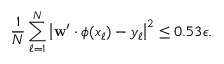<formula> <loc_0><loc_0><loc_500><loc_500>\frac { 1 } { N } \sum _ { \ell = 1 } ^ { N } \left | w ^ { \prime } \cdot \phi ( x _ { \ell } ) - y _ { \ell } \right | ^ { 2 } \leq 0 . 5 3 \epsilon .</formula> 